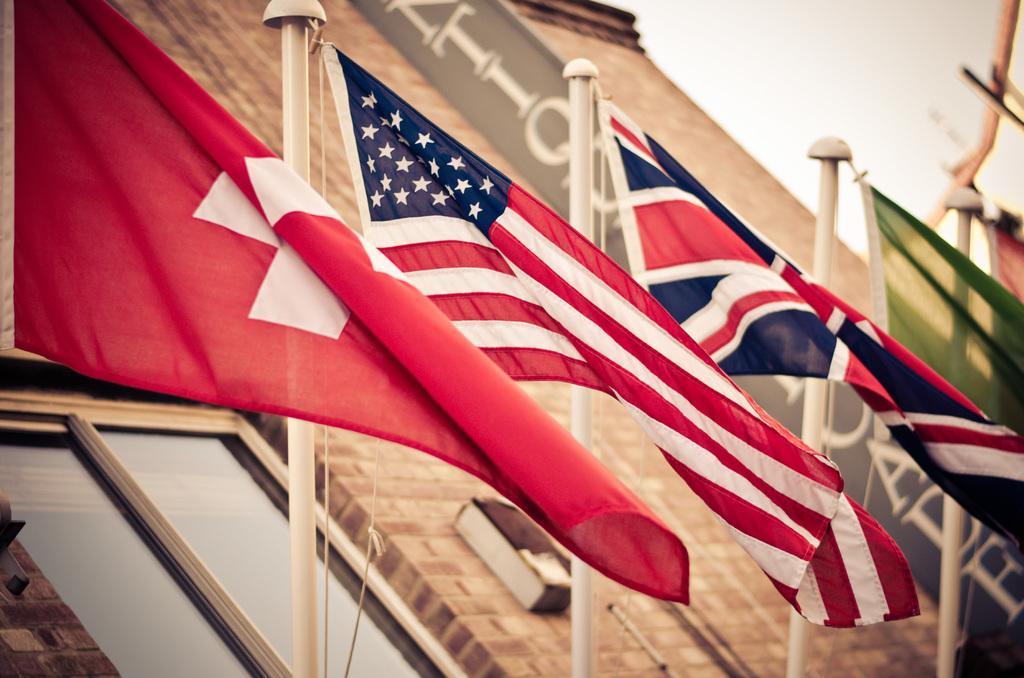What can be seen in the image that represents a symbol or country? There are flags in the image. How are the flags displayed in the image? The flags are attached to poles and ropes. What architectural feature can be seen in the image? There is a window in the image. What is hanging in the image besides the flags? There is a banner in the image. What is written on the banner? There is text on the banner. What part of the natural environment is visible in the image? The sky is visible in the image. Can you describe the picture of a tent in the image? There is no picture of a tent present in the image. How does the banner walk around in the image? The banner does not walk around in the image; it is stationary and hung up. 